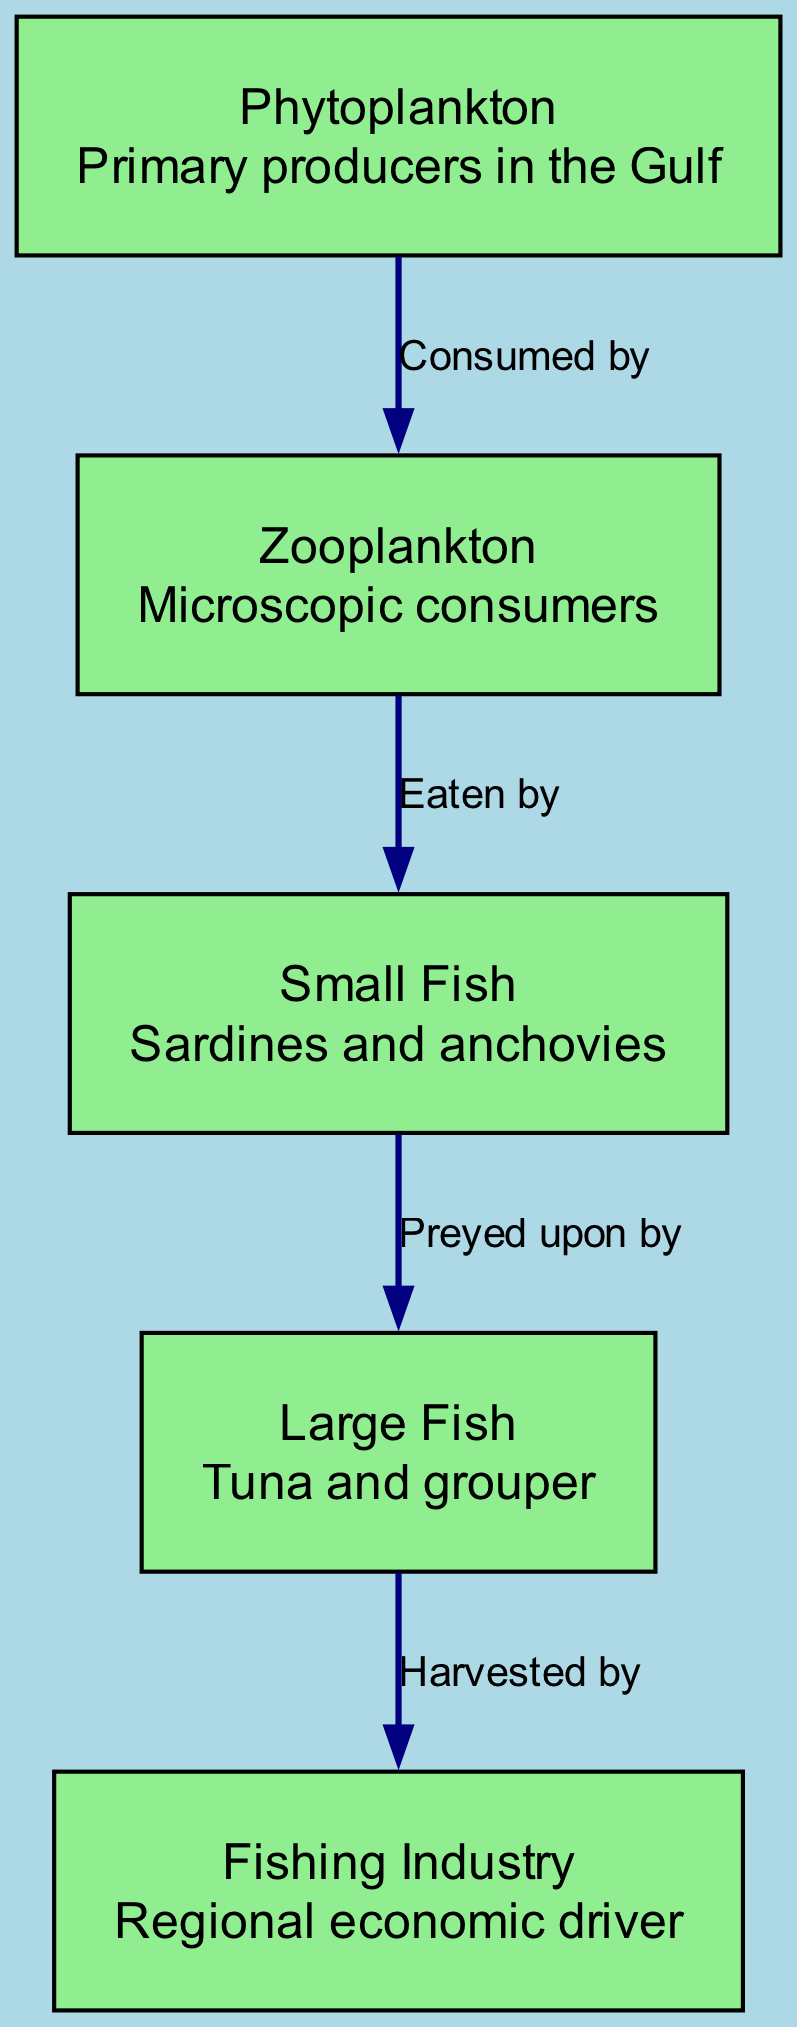What is the primary producer in the Gulf? According to the diagram, the primary producer identified is Phytoplankton, as it is the first node in the food chain and serves as the foundation for other organisms.
Answer: Phytoplankton How many nodes are present in the diagram? The diagram contains five nodes which are Phytoplankton, Zooplankton, Small Fish, Large Fish, and Fishing Industry. By counting them, we arrive at the total number of nodes.
Answer: 5 What is the relationship between Zooplankton and Small Fish? The edge connecting Zooplankton to Small Fish is labeled "Eaten by," indicating that Small Fish are consumers that feed on Zooplankton. This relationship shows the flow of energy from Zooplankton to Small Fish in the food chain.
Answer: Eaten by Which entity is harvested by the Fishing Industry? The diagram shows that Large Fish are the final consumer that is harvested by the Fishing Industry, as indicated by the edge connecting them with the label "Harvested by."
Answer: Large Fish What type of fish is identified as prey for Large Fish? The diagram specifies that Small Fish such as Sardines and Anchovies are preyed upon by Large Fish, making them a lower trophic level in this food chain.
Answer: Small Fish How does the food chain impact the regional fishing economy? The Fishing Industry is at the end of the food chain, indicating that its success depends directly on the abundance of Large Fish, which rely on the entire preceding chain. Thus, the stability and health of the food chain impact the fishing economy significantly.
Answer: Fishing Industry What is the first consumer in the food chain? The first consumer in the food chain, as shown in the flow of energy and nutrients, is Zooplankton, which consumes Phytoplankton. Thus, it represents the first level of consumption in this ecological hierarchy.
Answer: Zooplankton How many edges are described in the diagram? The total number of edges in the diagram is four, which represent the relationships between the different nodes in the food chain, connecting them sequentially.
Answer: 4 What type of relationship exists between Phytoplankton and Zooplankton? The edge labeled "Consumed by" indicates that Zooplankton derive their energy by consuming Phytoplankton, thus establishing a direct relationship in the energy flow.
Answer: Consumed by 